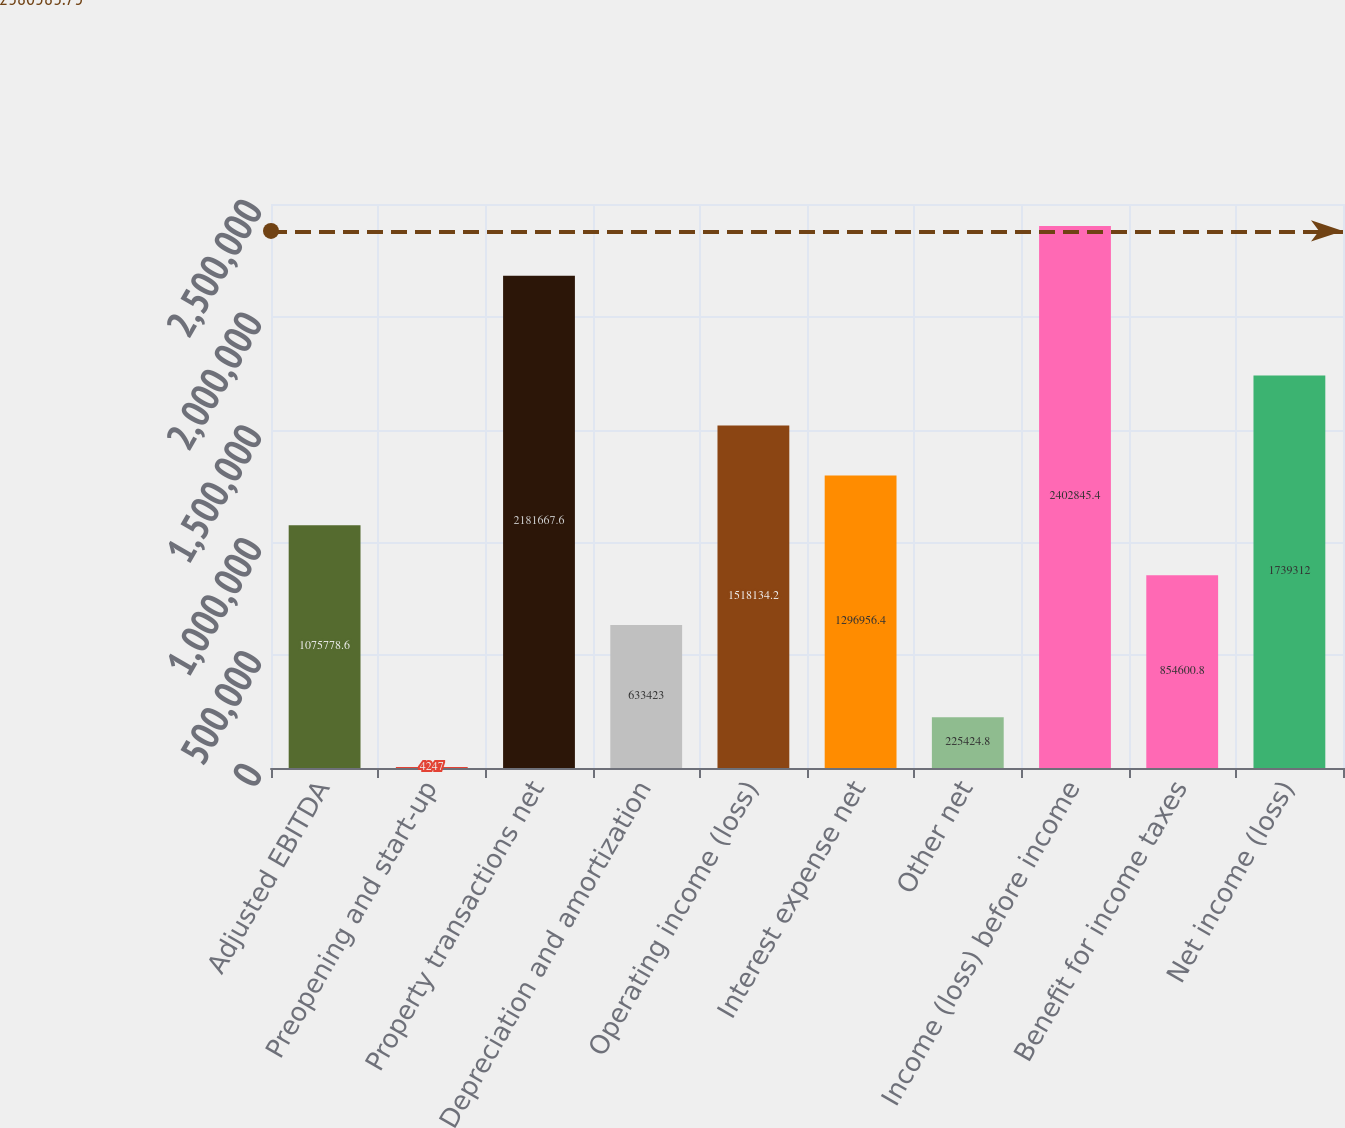Convert chart to OTSL. <chart><loc_0><loc_0><loc_500><loc_500><bar_chart><fcel>Adjusted EBITDA<fcel>Preopening and start-up<fcel>Property transactions net<fcel>Depreciation and amortization<fcel>Operating income (loss)<fcel>Interest expense net<fcel>Other net<fcel>Income (loss) before income<fcel>Benefit for income taxes<fcel>Net income (loss)<nl><fcel>1.07578e+06<fcel>4247<fcel>2.18167e+06<fcel>633423<fcel>1.51813e+06<fcel>1.29696e+06<fcel>225425<fcel>2.40285e+06<fcel>854601<fcel>1.73931e+06<nl></chart> 